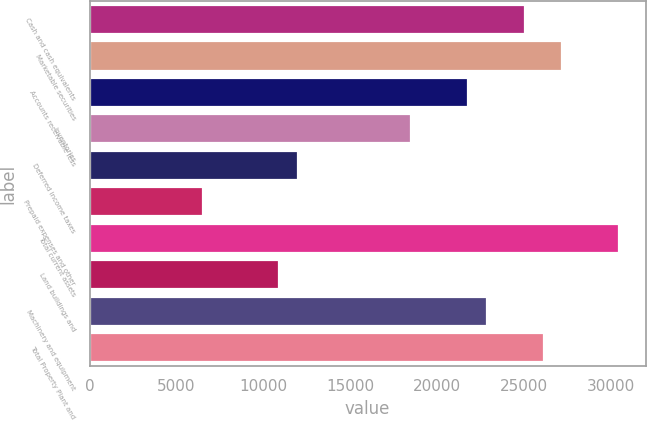Convert chart. <chart><loc_0><loc_0><loc_500><loc_500><bar_chart><fcel>Cash and cash equivalents<fcel>Marketable securities<fcel>Accounts receivable less<fcel>Inventories<fcel>Deferred income taxes<fcel>Prepaid expenses and other<fcel>Total current assets<fcel>Land buildings and<fcel>Machinery and equipment<fcel>Total Property Plant and<nl><fcel>25025.8<fcel>27199.8<fcel>21764.9<fcel>18504<fcel>11982.1<fcel>6547.18<fcel>30460.7<fcel>10895.1<fcel>22851.9<fcel>26112.8<nl></chart> 